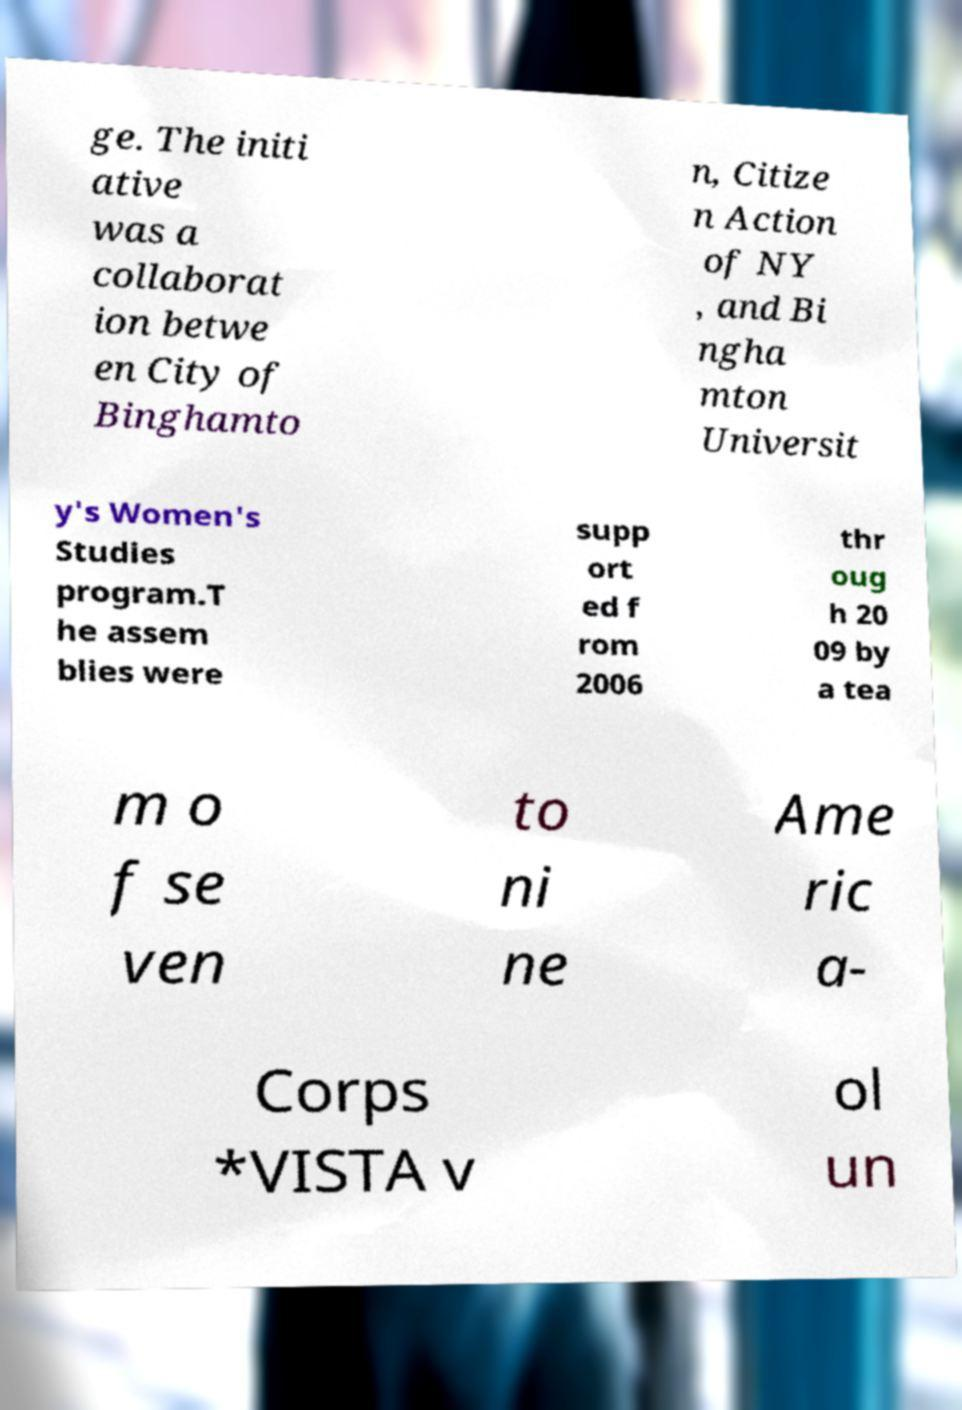What messages or text are displayed in this image? I need them in a readable, typed format. ge. The initi ative was a collaborat ion betwe en City of Binghamto n, Citize n Action of NY , and Bi ngha mton Universit y's Women's Studies program.T he assem blies were supp ort ed f rom 2006 thr oug h 20 09 by a tea m o f se ven to ni ne Ame ric a- Corps *VISTA v ol un 